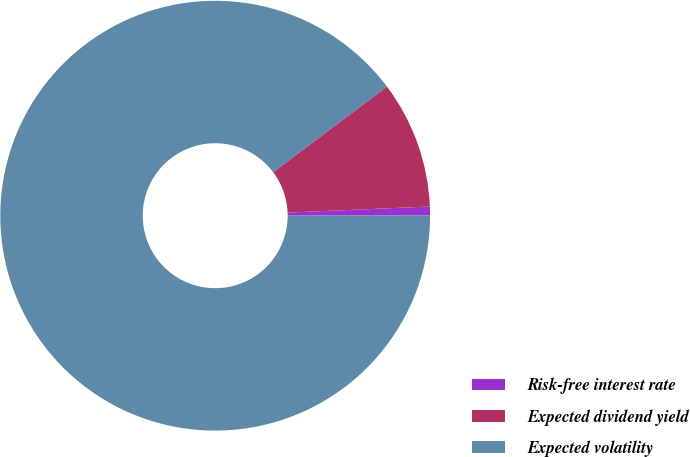Convert chart. <chart><loc_0><loc_0><loc_500><loc_500><pie_chart><fcel>Risk-free interest rate<fcel>Expected dividend yield<fcel>Expected volatility<nl><fcel>0.67%<fcel>9.58%<fcel>89.74%<nl></chart> 